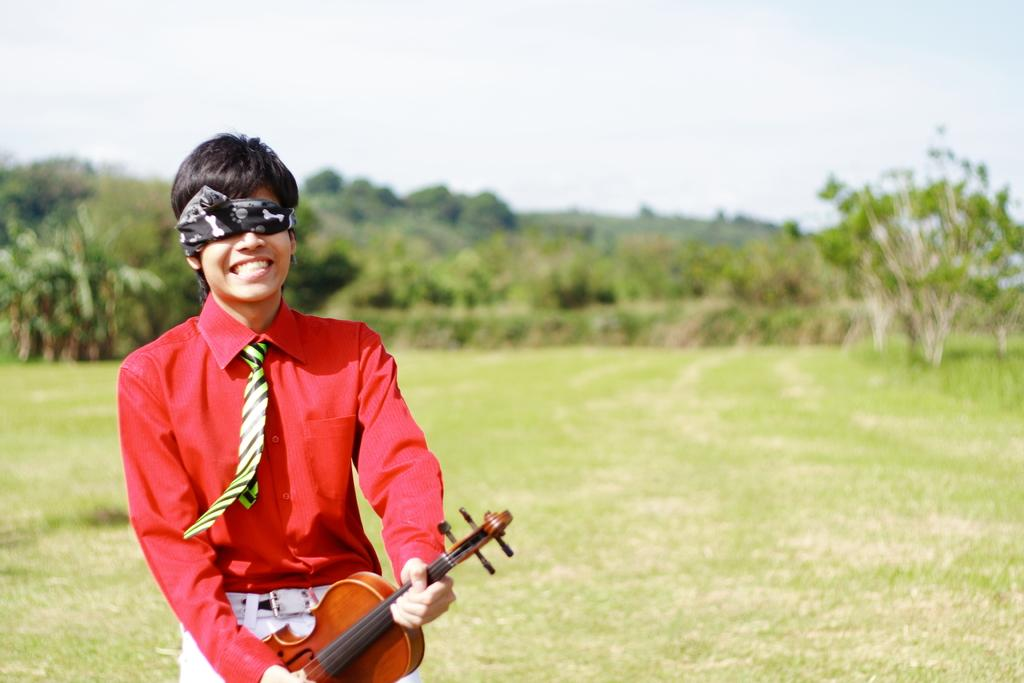Who is present in the image? There is a man in the image. What is the man holding in the image? The man is holding a musical instrument. What is the man doing with his eyes in the image? The man has covered his eyes. What can be seen in the background of the image? There are trees in the background of the image. What type of reaction can be seen on the shelf in the image? There is no shelf present in the image, and therefore no reaction can be observed on it. 